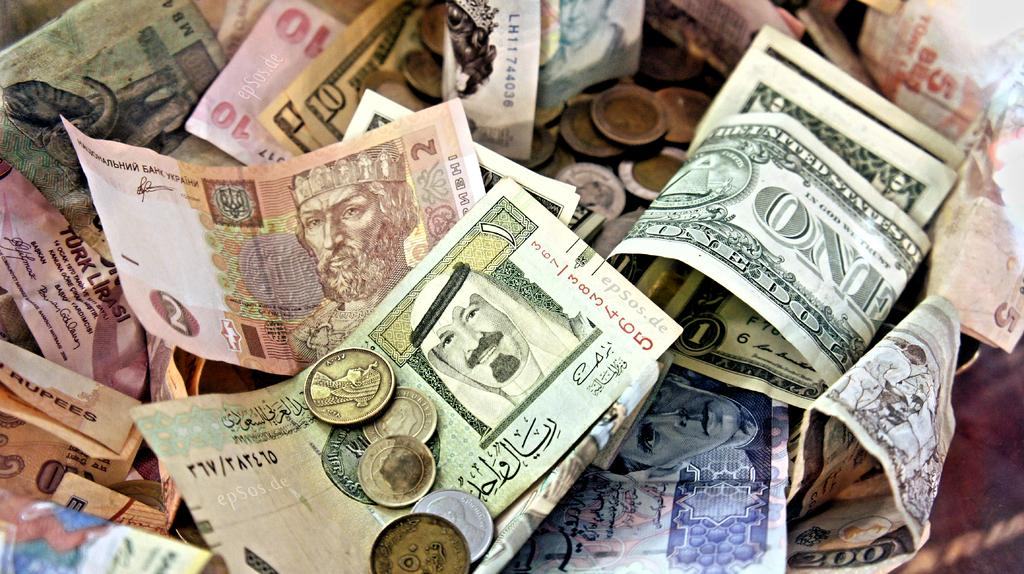What type of financial items are present in the image? There are many currency notes and a few coins in the image. What type of meal is being prepared with the currency notes in the image? There is no meal being prepared in the image; it only features currency notes and coins. How does the thumb interact with the currency notes in the image? There is no thumb present in the image; it only features currency notes and coins. 